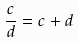Convert formula to latex. <formula><loc_0><loc_0><loc_500><loc_500>\frac { c } { d } = c + d</formula> 